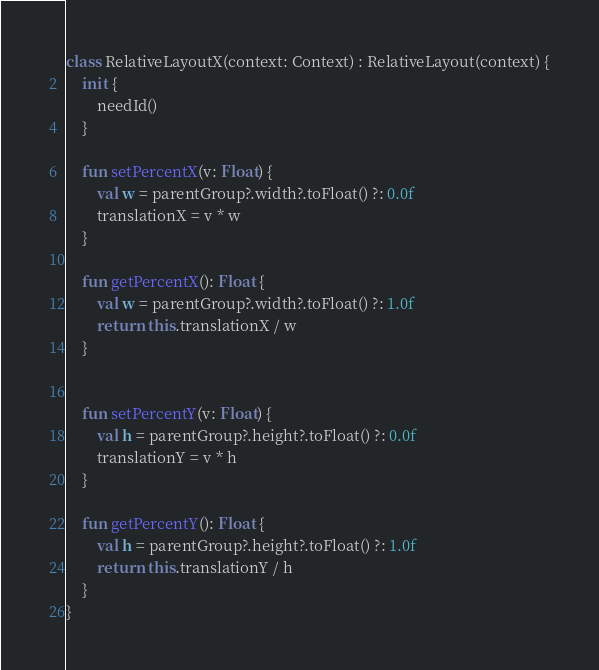<code> <loc_0><loc_0><loc_500><loc_500><_Kotlin_>class RelativeLayoutX(context: Context) : RelativeLayout(context) {
	init {
		needId()
	}

	fun setPercentX(v: Float) {
		val w = parentGroup?.width?.toFloat() ?: 0.0f
		translationX = v * w
	}

	fun getPercentX(): Float {
		val w = parentGroup?.width?.toFloat() ?: 1.0f
		return this.translationX / w
	}


	fun setPercentY(v: Float) {
		val h = parentGroup?.height?.toFloat() ?: 0.0f
		translationY = v * h
	}

	fun getPercentY(): Float {
		val h = parentGroup?.height?.toFloat() ?: 1.0f
		return this.translationY / h
	}
}</code> 